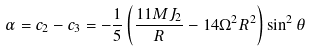<formula> <loc_0><loc_0><loc_500><loc_500>\alpha = c _ { 2 } - c _ { 3 } = - \frac { 1 } { 5 } \left ( \frac { 1 1 M J _ { 2 } } { R } - 1 4 \Omega ^ { 2 } R ^ { 2 } \right ) \sin ^ { 2 } \theta</formula> 